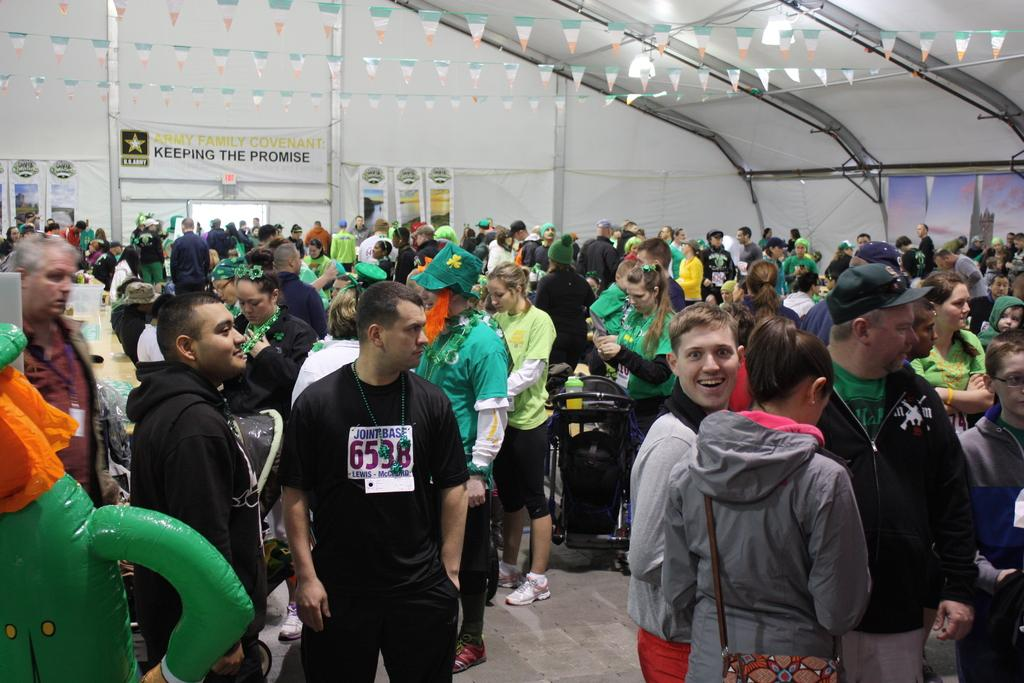Where was the image taken? The image was taken inside a room. How many people are present in the room? There are many people standing in the room. What can be seen on the left side of the room? There is a table on the left side of the room. What is visible in the background of the room? There is a wall in the background of the room. What is attached to the wall? There are banners on the wall. What type of soap is being used by the people in the image? There is no soap present in the image; it is taken inside a room with many people standing and a table, wall, and banners visible. 